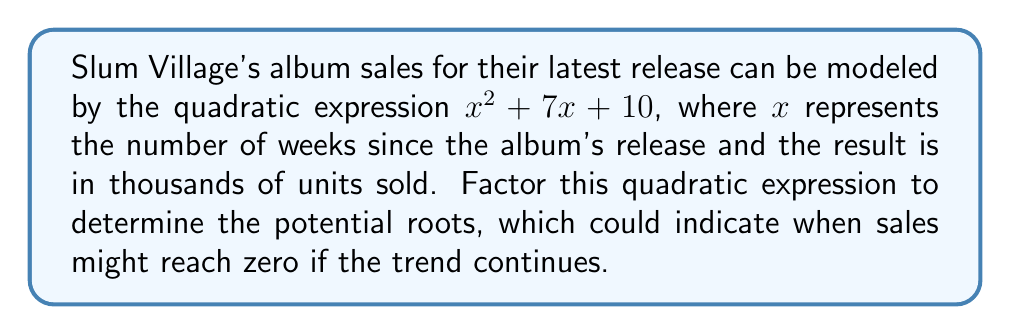Show me your answer to this math problem. To factor the quadratic expression $x^2 + 7x + 10$, we need to find two numbers that multiply to give the constant term (10) and add up to give the coefficient of $x$ (7).

1) First, list the factor pairs of 10:
   1 and 10
   2 and 5

2) Check which pair adds up to 7:
   1 + 10 = 11
   2 + 5 = 7

3) We found that 2 and 5 work. So we can rewrite the middle term:
   $x^2 + 7x + 10 = x^2 + 2x + 5x + 10$

4) Now we can group the terms:
   $(x^2 + 2x) + (5x + 10)$

5) Factor out the common factors from each group:
   $x(x + 2) + 5(x + 2)$

6) We can see that $(x + 2)$ is common to both terms, so we can factor it out:
   $(x + 2)(x + 5)$

Thus, the factored form of $x^2 + 7x + 10$ is $(x + 2)(x + 5)$.
Answer: $(x + 2)(x + 5)$ 